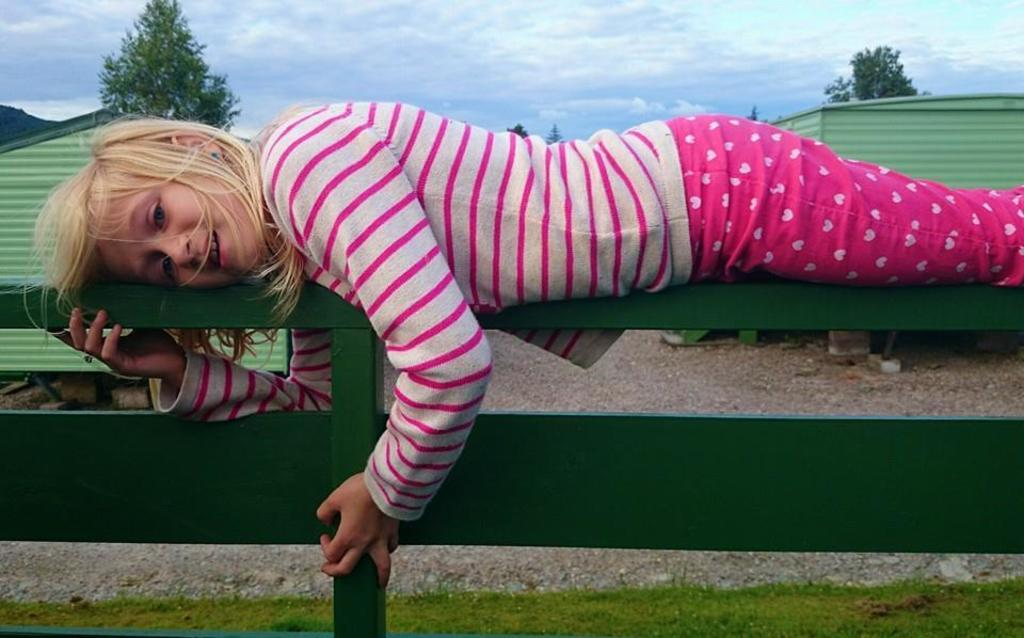Who is the main subject in the image? There is a girl in the image. What is the girl wearing? The girl is wearing a pink dress. What can be seen in the middle of the image? There are houses in the middle of the image. What type of vegetation is at the top of the image? There are trees at the top of the image. What is visible at the very top of the image? The sky is visible at the top of the image. What type of animal can be seen shaking hands with the girl in the image? There is no animal present in the image, nor is there any indication of an animal shaking hands with the girl. 